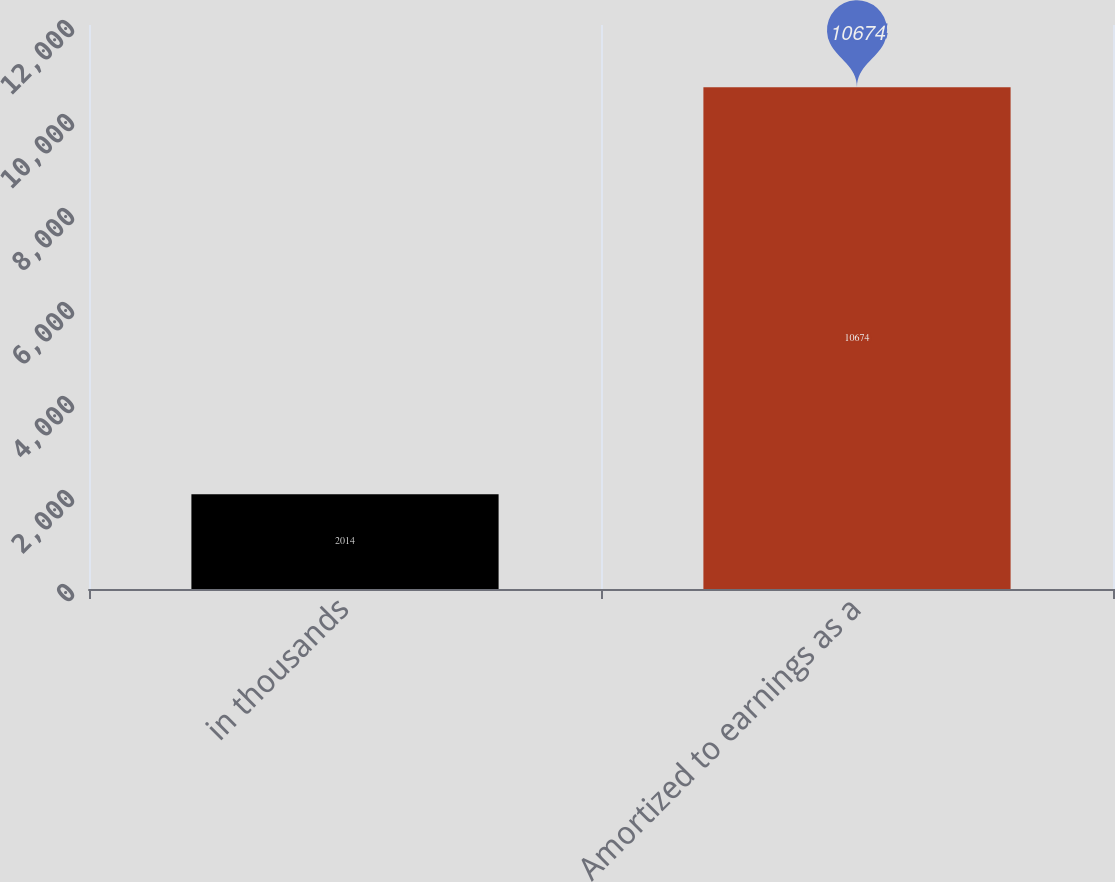<chart> <loc_0><loc_0><loc_500><loc_500><bar_chart><fcel>in thousands<fcel>Amortized to earnings as a<nl><fcel>2014<fcel>10674<nl></chart> 